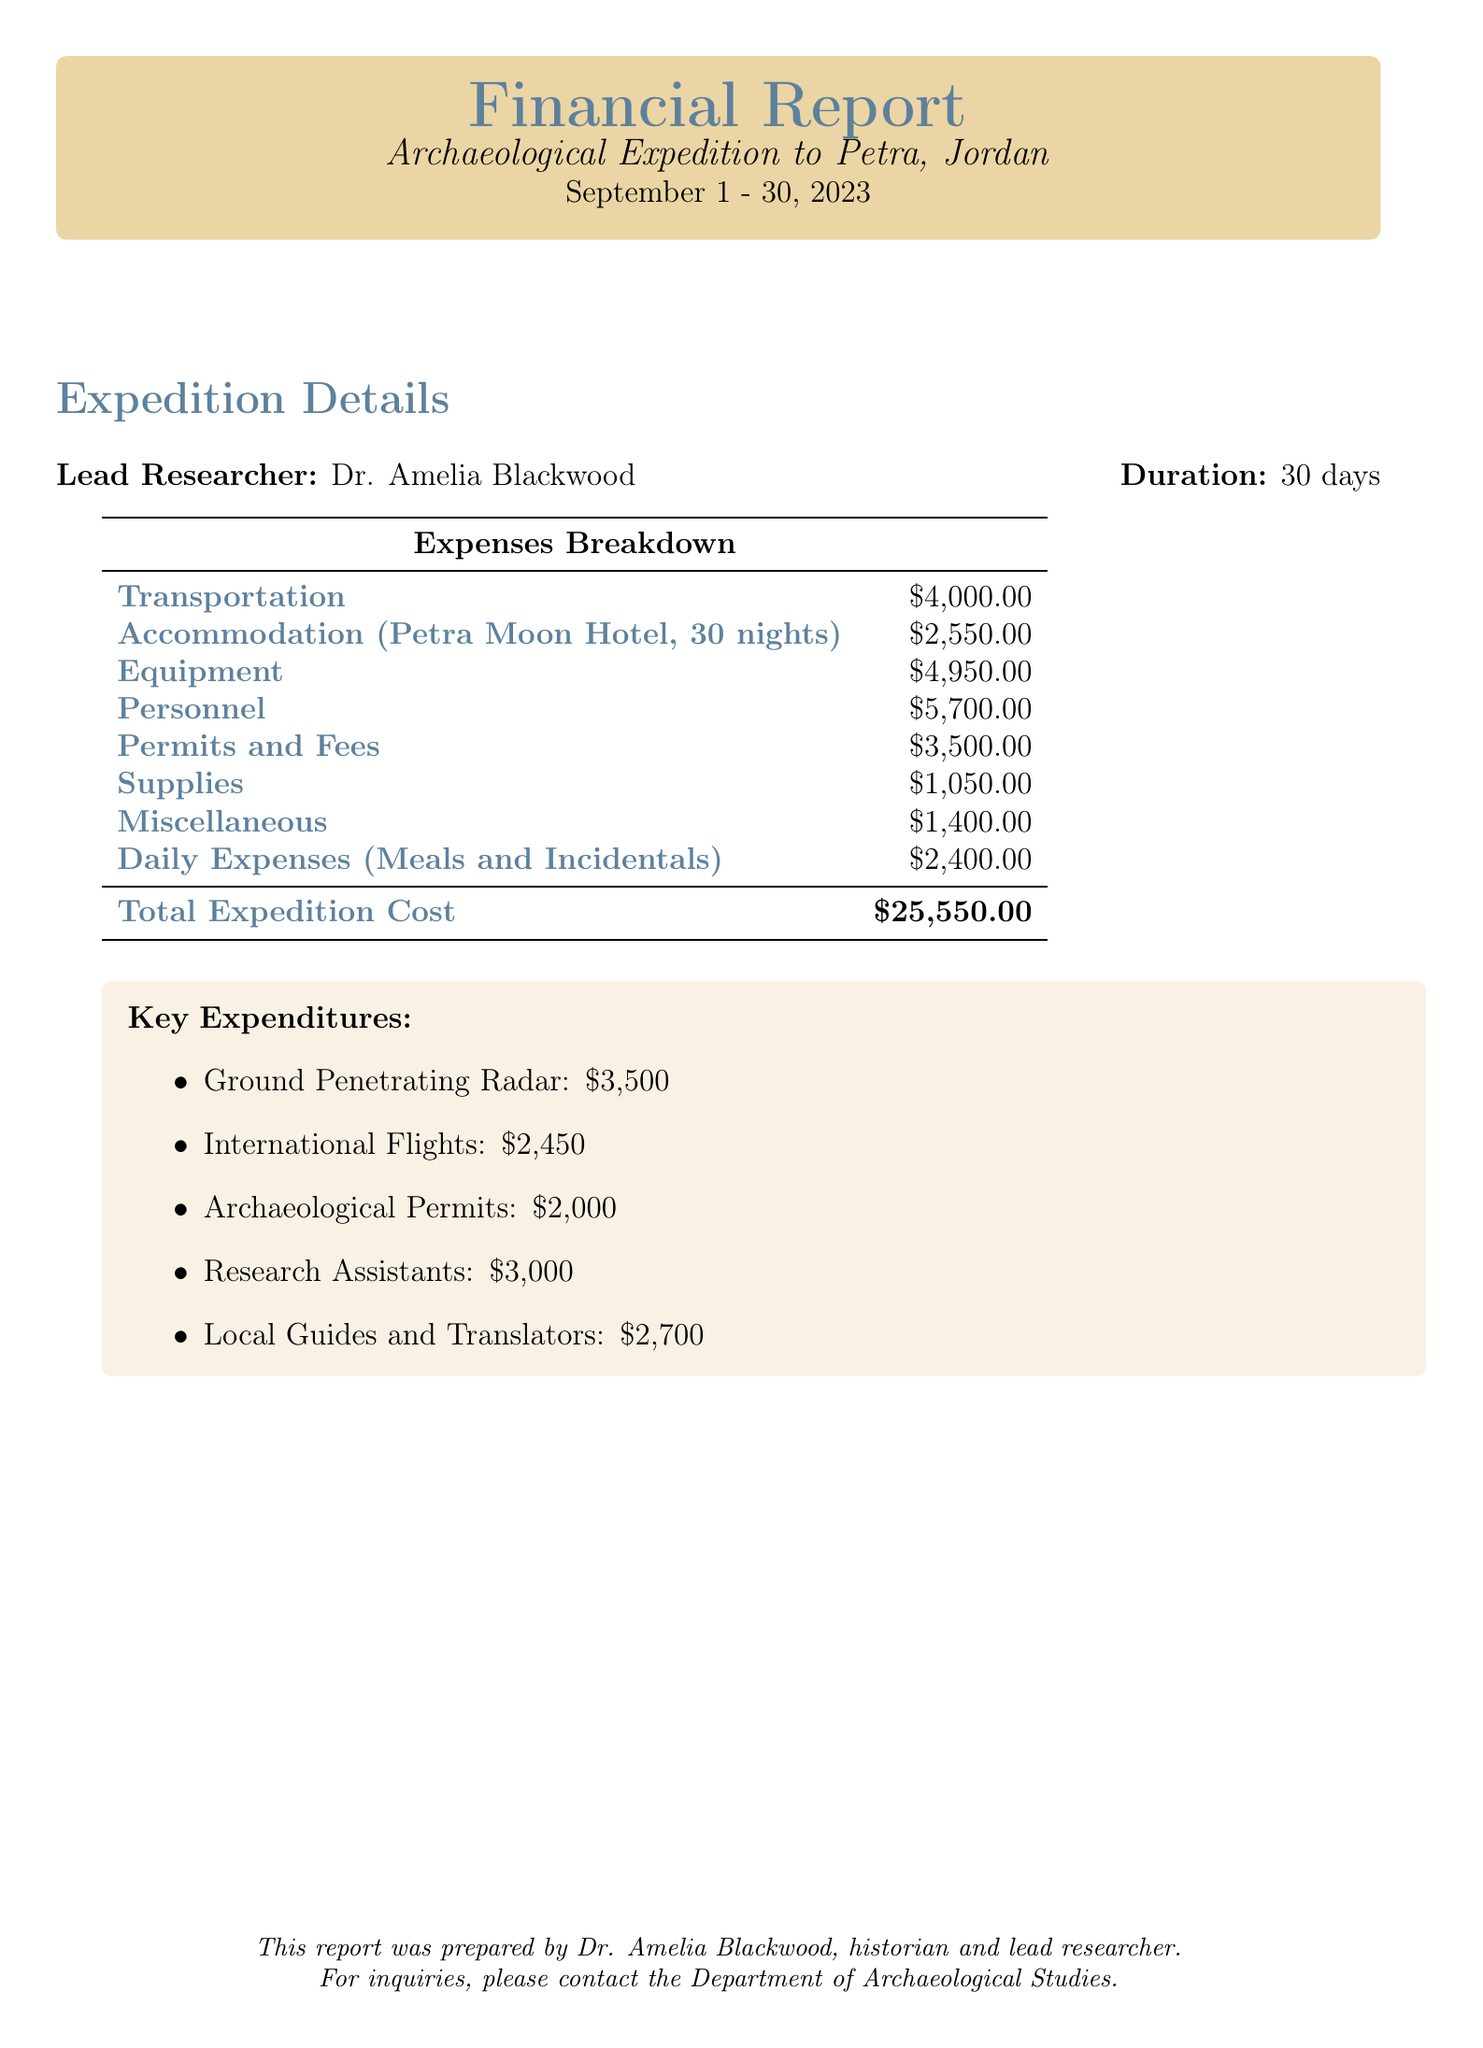What is the total cost of transportation? The total transportation cost includes international flights and local transportation amounts, which equals $2,450 + $1,200 + $350 = $4,000.
Answer: $4,000 What is the cost for ground penetrating radar? The document states that the cost for ground penetrating radar is explicitly mentioned as $3,500.
Answer: $3,500 Who is the lead researcher of the expedition? The document names Dr. Amelia Blackwood as the lead researcher of the archaeological expedition.
Answer: Dr. Amelia Blackwood How many nights were spent at the Petra Moon Hotel? The report specifies that the team stayed for a total of 30 nights at the hotel.
Answer: 30 nights What is the total amount spent on permits and fees? The total spent on permits and fees is the sum of archaeological permits and site access fees, which is $2,000 + $1,500 = $3,500.
Answer: $3,500 What is included in the miscellaneous expenses? The miscellaneous expenses consist of travel insurance and an emergency fund, totaling $400 + $1,000 = $1,400.
Answer: Travel insurance, emergency fund How much did the research assistants cost? The document specifies the cost for research assistants as $3,000.
Answer: $3,000 What is the total expedition cost? The report calculates the total cost by adding up all the expenses listed, which amounts to $25,550.
Answer: $25,550 Which hotel was used for accommodation? The document explicitly mentions the Petra Moon Hotel as the accommodation for the expedition.
Answer: Petra Moon Hotel 